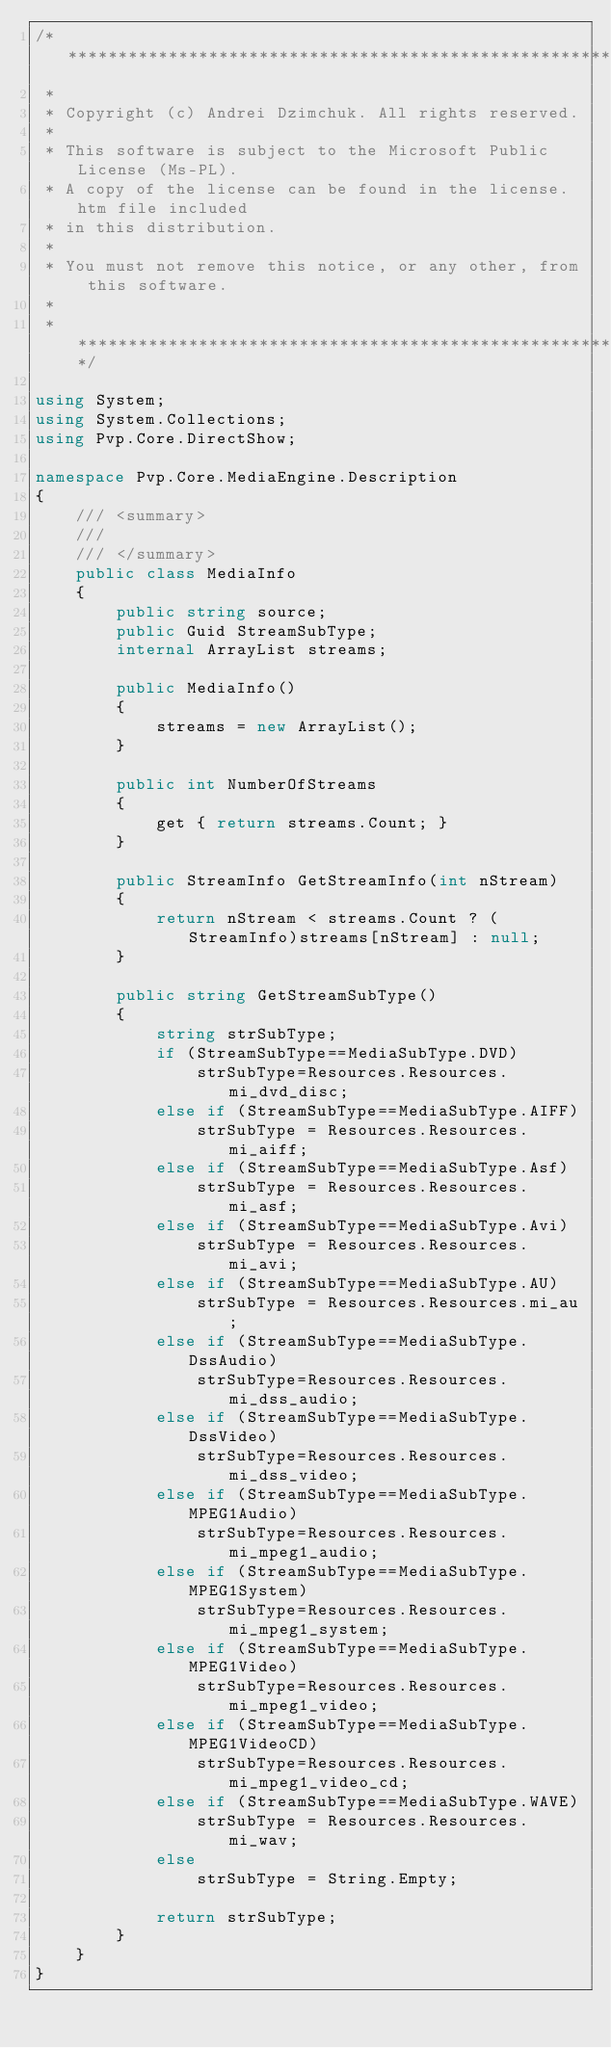<code> <loc_0><loc_0><loc_500><loc_500><_C#_>/* ****************************************************************************
 *
 * Copyright (c) Andrei Dzimchuk. All rights reserved.
 *
 * This software is subject to the Microsoft Public License (Ms-PL). 
 * A copy of the license can be found in the license.htm file included 
 * in this distribution.
 *
 * You must not remove this notice, or any other, from this software.
 *
 * ***************************************************************************/

using System;
using System.Collections;
using Pvp.Core.DirectShow;

namespace Pvp.Core.MediaEngine.Description
{
    /// <summary>
    /// 
    /// </summary>
    public class MediaInfo
    {
        public string source;
        public Guid StreamSubType;
        internal ArrayList streams;
        
        public MediaInfo()
        {
            streams = new ArrayList();
        }

        public int NumberOfStreams
        {
            get { return streams.Count; }
        }

        public StreamInfo GetStreamInfo(int nStream)
        {
            return nStream < streams.Count ? (StreamInfo)streams[nStream] : null;
        }

        public string GetStreamSubType()
        {
            string strSubType;
            if (StreamSubType==MediaSubType.DVD)
                strSubType=Resources.Resources.mi_dvd_disc;
            else if (StreamSubType==MediaSubType.AIFF)
                strSubType = Resources.Resources.mi_aiff;
            else if (StreamSubType==MediaSubType.Asf)
                strSubType = Resources.Resources.mi_asf;
            else if (StreamSubType==MediaSubType.Avi)
                strSubType = Resources.Resources.mi_avi;
            else if (StreamSubType==MediaSubType.AU)
                strSubType = Resources.Resources.mi_au;
            else if (StreamSubType==MediaSubType.DssAudio)
                strSubType=Resources.Resources.mi_dss_audio;
            else if (StreamSubType==MediaSubType.DssVideo)
                strSubType=Resources.Resources.mi_dss_video;
            else if (StreamSubType==MediaSubType.MPEG1Audio)
                strSubType=Resources.Resources.mi_mpeg1_audio;
            else if (StreamSubType==MediaSubType.MPEG1System)
                strSubType=Resources.Resources.mi_mpeg1_system;
            else if (StreamSubType==MediaSubType.MPEG1Video)
                strSubType=Resources.Resources.mi_mpeg1_video;
            else if (StreamSubType==MediaSubType.MPEG1VideoCD)
                strSubType=Resources.Resources.mi_mpeg1_video_cd;
            else if (StreamSubType==MediaSubType.WAVE)
                strSubType = Resources.Resources.mi_wav;
            else
                strSubType = String.Empty;
        
            return strSubType;
        }
    }
}
</code> 